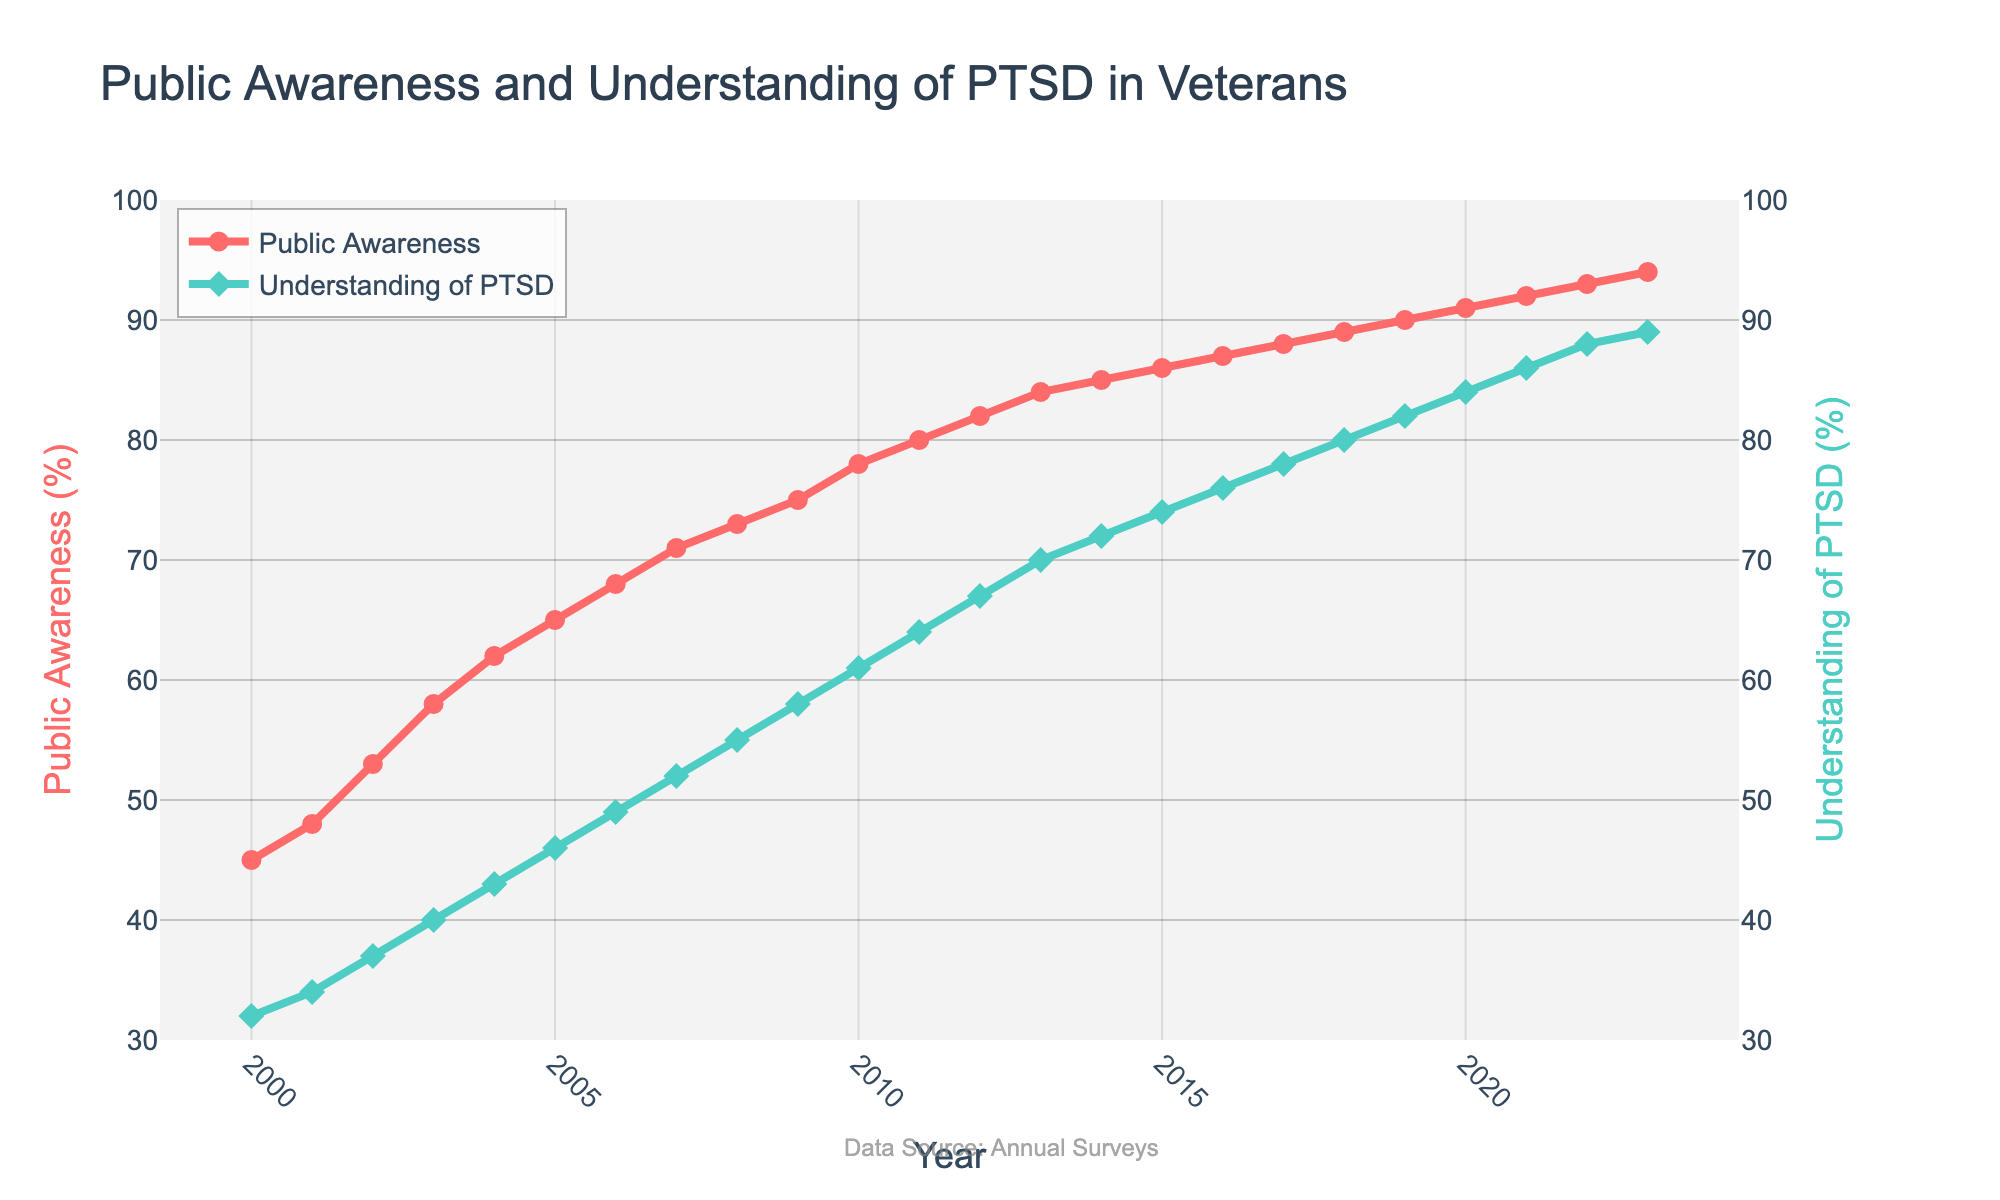What is the difference between public awareness and understanding of PTSD in the year 2000? In the year 2000, public awareness is at 45% while understanding is at 32%. The difference is obtained by subtracting the understanding value from the awareness value: 45% - 32% = 13%.
Answer: 13% Which year showed the highest increase in public awareness from the previous year? To determine the highest increase, calculate the difference in public awareness between consecutive years and find the maximum. The highest increase occurred from 2001 to 2002, where there was an increase from 48% to 53%, which equals a 5% increase.
Answer: 2002 What is the average public awareness percentage from 2000 to 2023? Sum all the public awareness values from 2000 to 2023 and divide by the number of years (24). The total is 1775%, so the average is 1775 / 24 ≈ 73.96%.
Answer: 73.96% How do the trends of public awareness and understanding of PTSD compare? Both public awareness and understanding of PTSD exhibit an upward trend from 2000 to 2023, with public awareness consistently being higher than understanding of PTSD. The trend slopes for both metrics are positive and they increase almost in parallel.
Answer: Both trends are upward, with awareness higher than understanding By how much did understanding of PTSD improve from 2010 to 2020? Understanding of PTSD improved from 61% in 2010 to 84% in 2020. The improvement is calculated as 84% - 61% = 23%.
Answer: 23% In which year did public awareness reach 90%? Public awareness reached 90% in the year 2019, as indicated by the data point on the graph.
Answer: 2019 Which has a steeper slope from 2000 to 2023, public awareness or understanding of PTSD? To determine the steeper slope, compare the overall rate of increase. Public awareness increased from 45% to 94%, a total increase of 49%, and understanding of PTSD increased from 32% to 89%, a total increase of 57%. Given that understanding of PTSD had a 57% increase over the same time span as the 49% increase in public awareness, understanding of PTSD has a steeper slope.
Answer: Understanding of PTSD What can you infer about public interest in PTSD over the years based on the graph colors? The graph uses red for public awareness and green for understanding of PTSD. From 2000 to 2023, both lines show an increase, signifying growing public interest, with the red showing higher values, indicating greater awareness throughout the period.
Answer: Growing public interest; awareness is higher How did public understanding of PTSD change from 2007 to 2013? In 2007, public understanding was at 52%, and by 2013 it had increased to 70%. The change is calculated as 70% - 52% = 18%.
Answer: 18% When did understanding of PTSD surpass 70%? Understanding of PTSD first surpassed 70% in the year 2014, as indicated by the data points on the graph.
Answer: 2014 